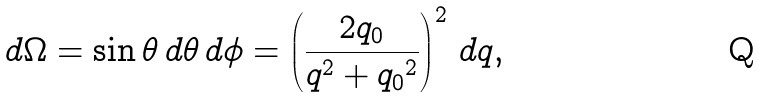<formula> <loc_0><loc_0><loc_500><loc_500>d \Omega = \sin \theta \, d \theta \, d \phi = \left ( \frac { 2 q _ { 0 } } { q ^ { 2 } + { q _ { 0 } } ^ { 2 } } \right ) ^ { 2 } \, d q ,</formula> 